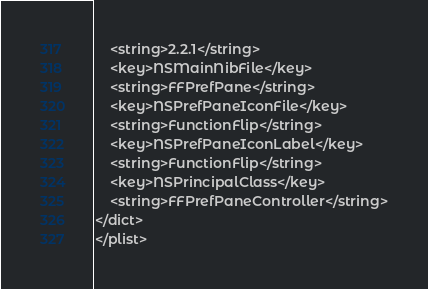Convert code to text. <code><loc_0><loc_0><loc_500><loc_500><_XML_>	<string>2.2.1</string>
	<key>NSMainNibFile</key>
	<string>FFPrefPane</string>
	<key>NSPrefPaneIconFile</key>
	<string>FunctionFlip</string>
	<key>NSPrefPaneIconLabel</key>
	<string>FunctionFlip</string>
	<key>NSPrincipalClass</key>
	<string>FFPrefPaneController</string>
</dict>
</plist>
</code> 